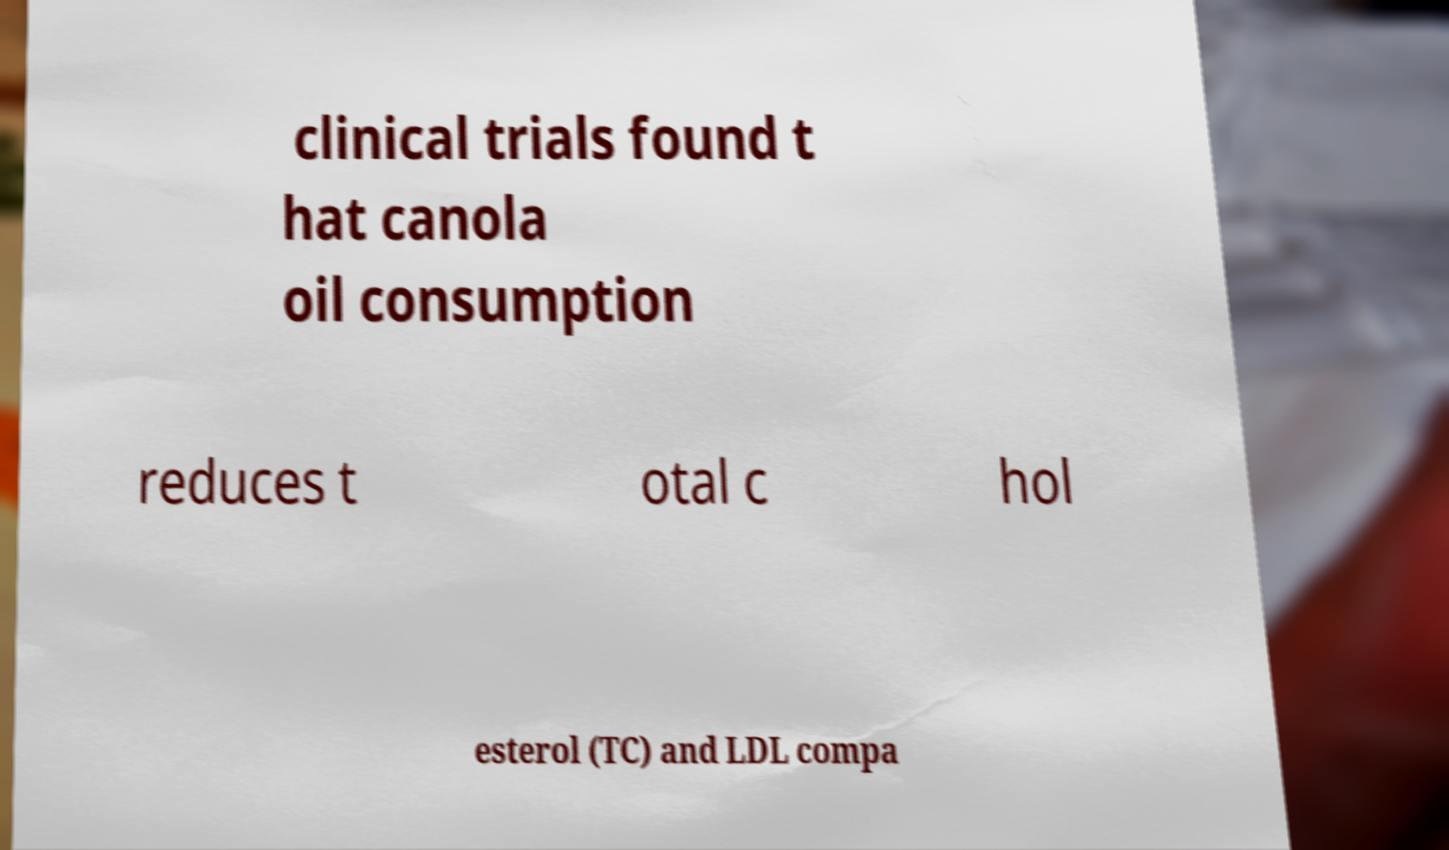For documentation purposes, I need the text within this image transcribed. Could you provide that? clinical trials found t hat canola oil consumption reduces t otal c hol esterol (TC) and LDL compa 